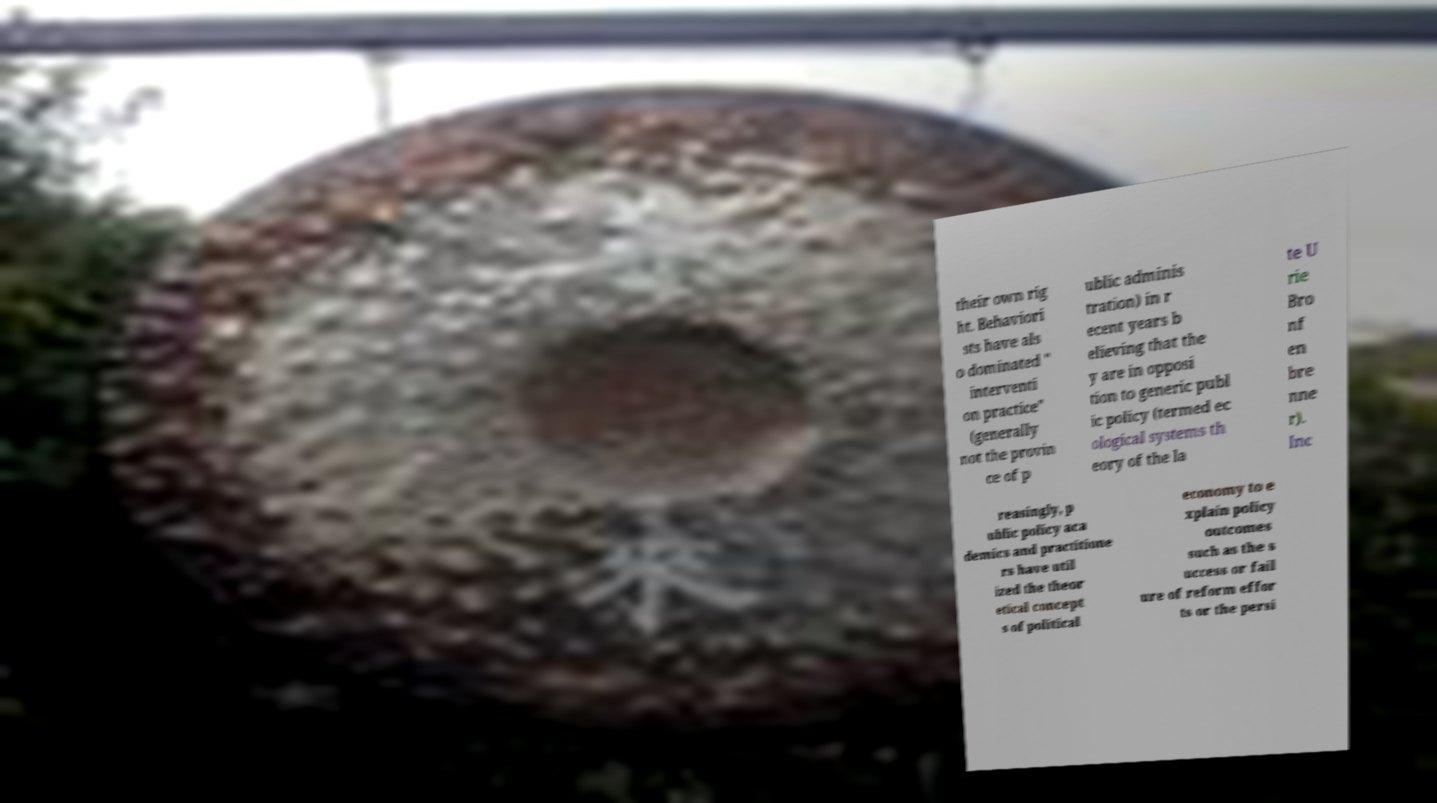Can you read and provide the text displayed in the image?This photo seems to have some interesting text. Can you extract and type it out for me? their own rig ht. Behaviori sts have als o dominated " interventi on practice" (generally not the provin ce of p ublic adminis tration) in r ecent years b elieving that the y are in opposi tion to generic publ ic policy (termed ec ological systems th eory of the la te U rie Bro nf en bre nne r). Inc reasingly, p ublic policy aca demics and practitione rs have util ized the theor etical concept s of political economy to e xplain policy outcomes such as the s uccess or fail ure of reform effor ts or the persi 